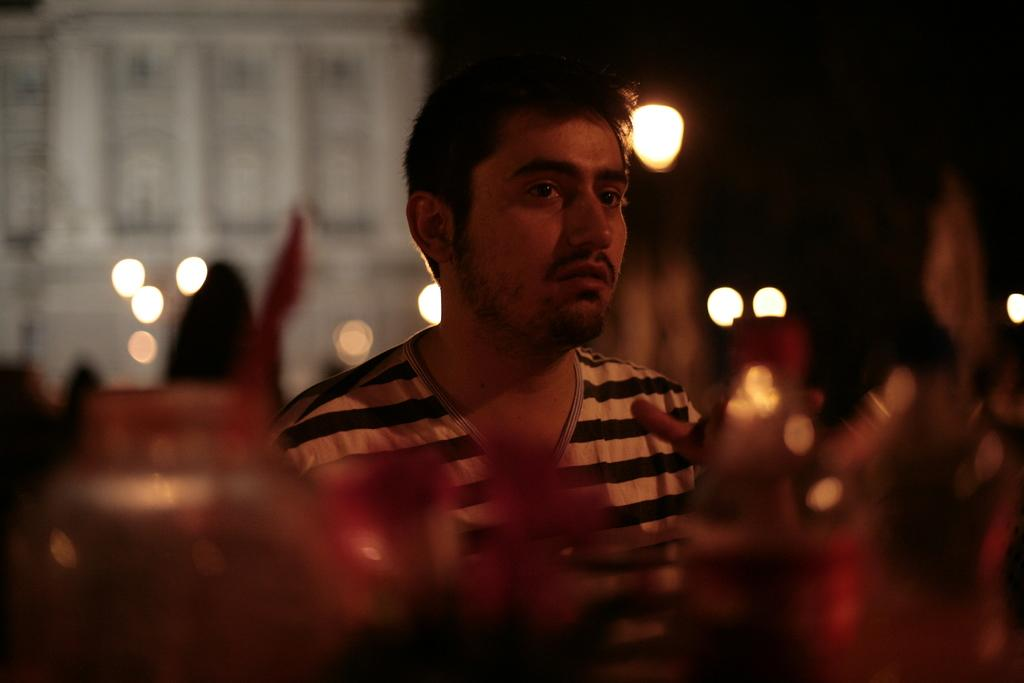Who is present in the image? There is a man in the image. What type of structure can be seen in the image? There is a building in the image. What can be seen illuminating the scene in the image? There are lights visible in the image. What type of produce is being sold by the man in the image? There is no produce present in the image; it only features a man, a building, and lights. 